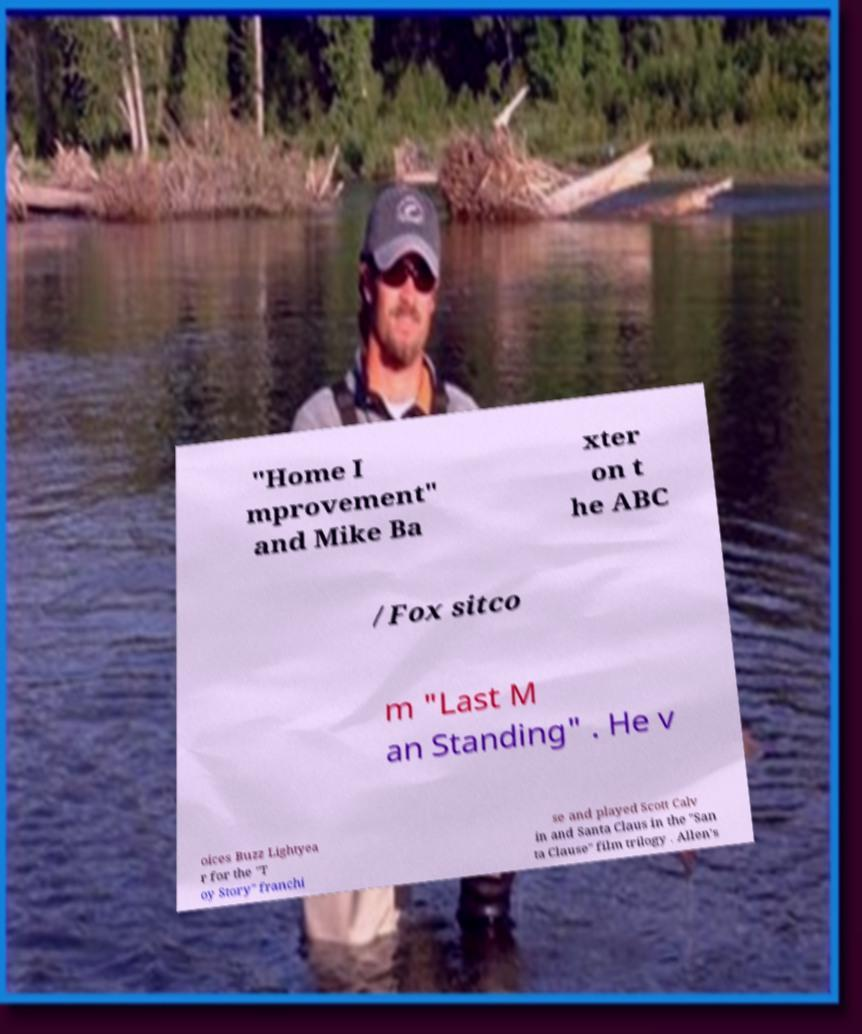For documentation purposes, I need the text within this image transcribed. Could you provide that? "Home I mprovement" and Mike Ba xter on t he ABC /Fox sitco m "Last M an Standing" . He v oices Buzz Lightyea r for the "T oy Story" franchi se and played Scott Calv in and Santa Claus in the "San ta Clause" film trilogy . Allen's 